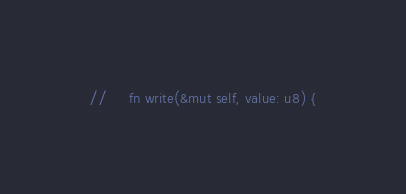<code> <loc_0><loc_0><loc_500><loc_500><_Rust_>//     fn write(&mut self, value: u8) {</code> 